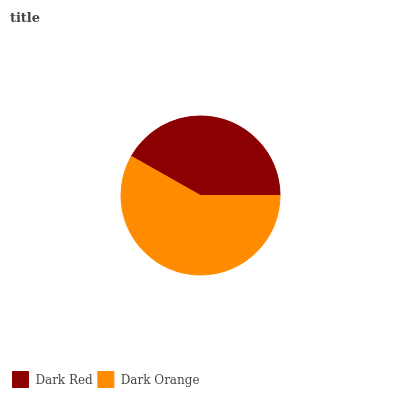Is Dark Red the minimum?
Answer yes or no. Yes. Is Dark Orange the maximum?
Answer yes or no. Yes. Is Dark Orange the minimum?
Answer yes or no. No. Is Dark Orange greater than Dark Red?
Answer yes or no. Yes. Is Dark Red less than Dark Orange?
Answer yes or no. Yes. Is Dark Red greater than Dark Orange?
Answer yes or no. No. Is Dark Orange less than Dark Red?
Answer yes or no. No. Is Dark Orange the high median?
Answer yes or no. Yes. Is Dark Red the low median?
Answer yes or no. Yes. Is Dark Red the high median?
Answer yes or no. No. Is Dark Orange the low median?
Answer yes or no. No. 